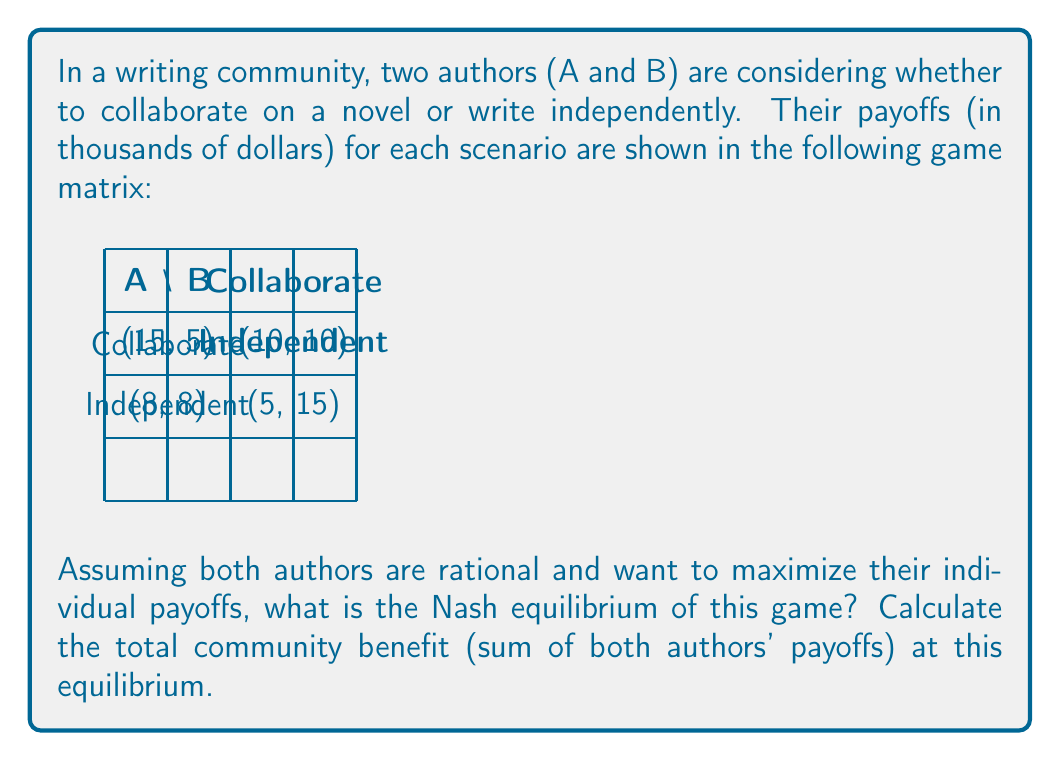Give your solution to this math problem. To solve this problem, we'll follow these steps:

1) Identify the Nash equilibrium:
   A Nash equilibrium is a set of strategies where no player can unilaterally improve their payoff by changing their strategy.

2) Check each strategy combination:
   a) (Collaborate, Collaborate): Payoff (10, 10)
      - If A switches to Independent, payoff becomes (15, 5)
      - If B switches to Independent, payoff becomes (5, 15)
      Both can improve by switching, so this is not a Nash equilibrium.

   b) (Collaborate, Independent): Payoff (5, 15)
      - If A switches to Independent, payoff becomes (8, 8)
      - B cannot improve by switching
      This is not a Nash equilibrium as A can improve.

   c) (Independent, Collaborate): Payoff (15, 5)
      - A cannot improve by switching
      - If B switches to Independent, payoff becomes (8, 8)
      This is not a Nash equilibrium as B can improve.

   d) (Independent, Independent): Payoff (8, 8)
      - If A switches to Collaborate, payoff becomes (5, 15)
      - If B switches to Collaborate, payoff becomes (15, 5)
      Neither can improve by switching, so this is a Nash equilibrium.

3) Calculate total community benefit:
   At the Nash equilibrium (Independent, Independent), the payoffs are (8, 8).
   Total community benefit = $8 + 8 = 16$ thousand dollars.

Therefore, the Nash equilibrium is (Independent, Independent), and the total community benefit at this equilibrium is $16,000.
Answer: Nash equilibrium: (Independent, Independent); Total community benefit: $16,000 